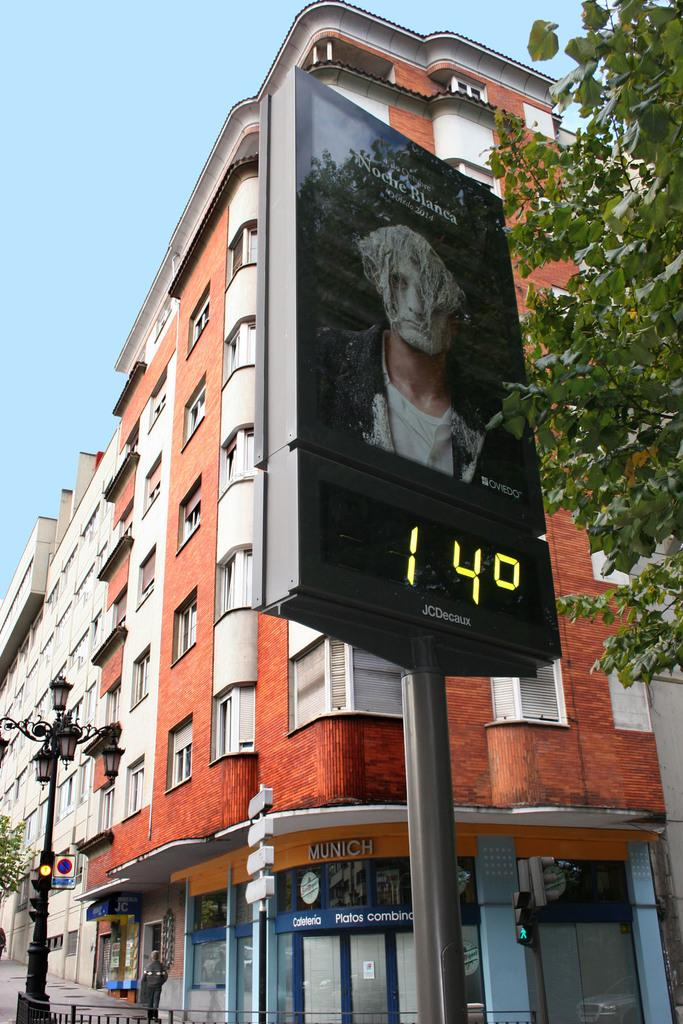What is the main object in the image? There is a board in the image. What else can be seen in the image besides the board? There is a pole, buildings, trees, and the sky visible in the image. Can you describe the surroundings of the board? The board is surrounded by buildings and trees, and the sky is visible in the background. What language is the baby speaking in the image? There is no baby present in the image, so it is not possible to determine what language they might be speaking. 